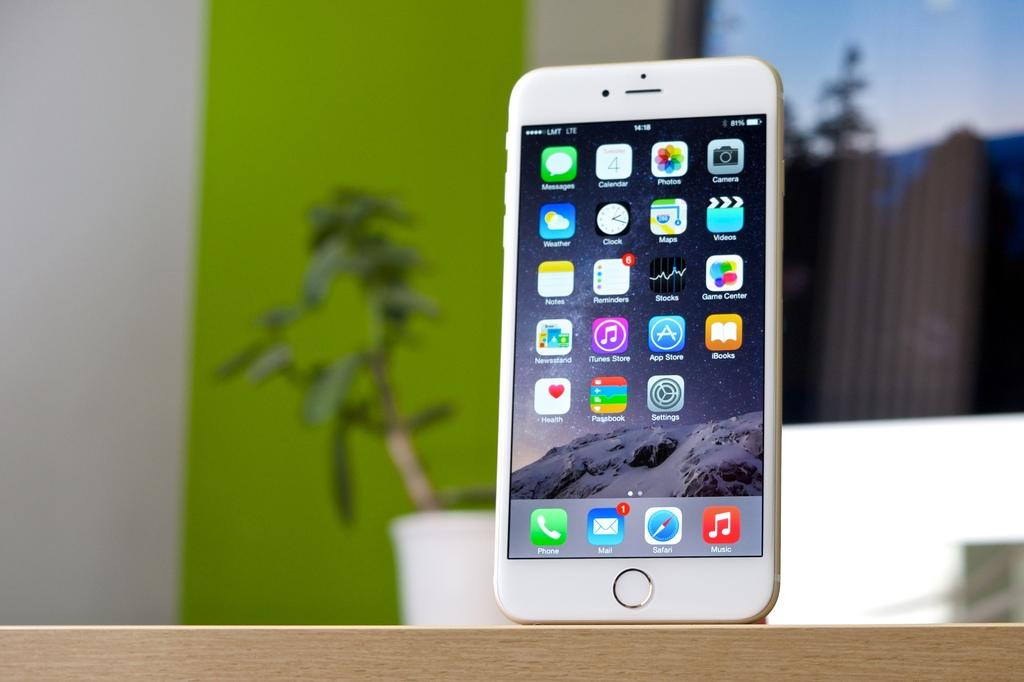<image>
Relay a brief, clear account of the picture shown. An iPhone has apps called phone, mail, Safari, and Music in the lower dock area. 